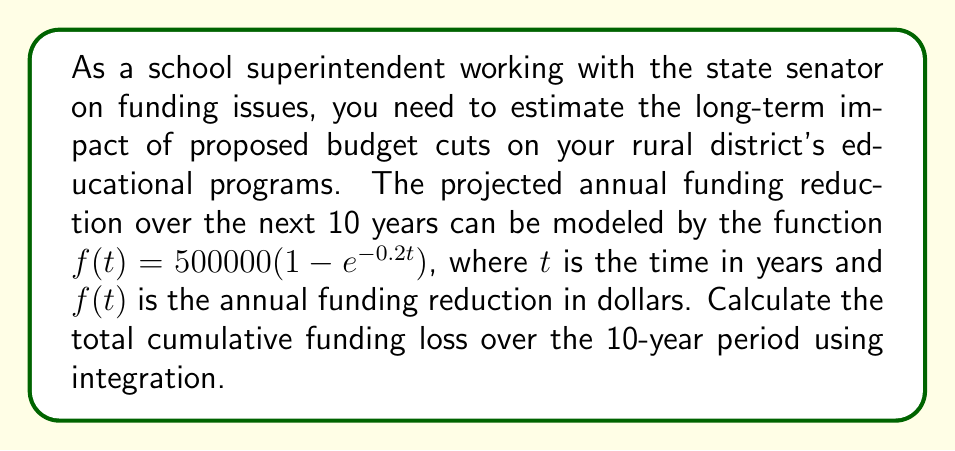Show me your answer to this math problem. To solve this problem, we need to integrate the given function over the interval [0, 10] to find the area under the curve, which represents the total cumulative funding loss.

1) The function to integrate is $f(t) = 500000(1 - e^{-0.2t})$

2) We need to calculate $\int_0^{10} f(t) dt$

3) Set up the integral:
   $$\int_0^{10} 500000(1 - e^{-0.2t}) dt$$

4) Distribute the constant:
   $$500000 \int_0^{10} (1 - e^{-0.2t}) dt$$

5) Integrate term by term:
   $$500000 \left[t + \frac{1}{0.2}e^{-0.2t}\right]_0^{10}$$

6) Evaluate the antiderivative at the bounds:
   $$500000 \left[(10 + \frac{1}{0.2}e^{-2}) - (0 + \frac{1}{0.2})\right]$$

7) Simplify:
   $$500000 \left[10 + 5e^{-2} - 5\right]$$
   $$500000 \left[5 + 5e^{-2}\right]$$

8) Calculate the final result:
   $$2500000 + 2500000e^{-2}$$
   $$\approx 2,500,000 + 339,957$$
   $$\approx 2,839,957$$

Therefore, the total cumulative funding loss over the 10-year period is approximately $2,839,957.
Answer: $2,839,957 